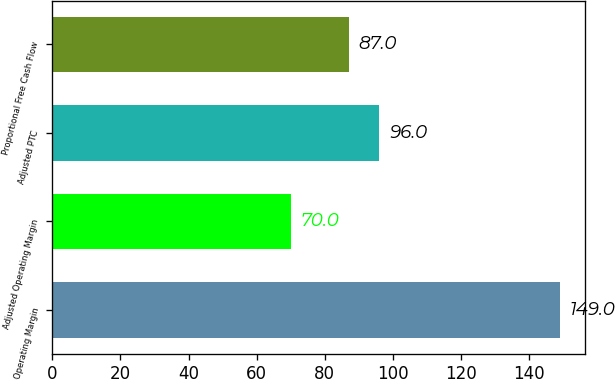Convert chart to OTSL. <chart><loc_0><loc_0><loc_500><loc_500><bar_chart><fcel>Operating Margin<fcel>Adjusted Operating Margin<fcel>Adjusted PTC<fcel>Proportional Free Cash Flow<nl><fcel>149<fcel>70<fcel>96<fcel>87<nl></chart> 